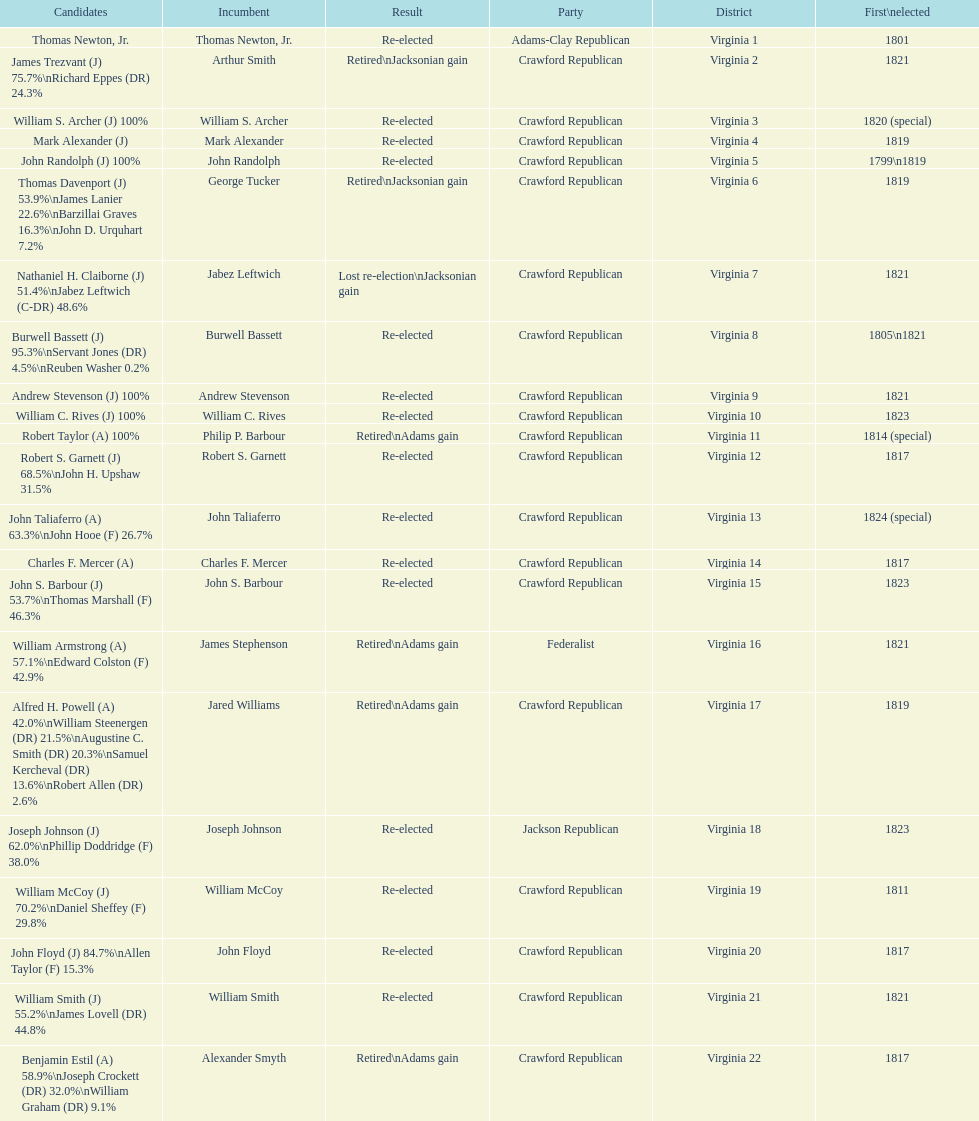What is the last party on this chart? Crawford Republican. 